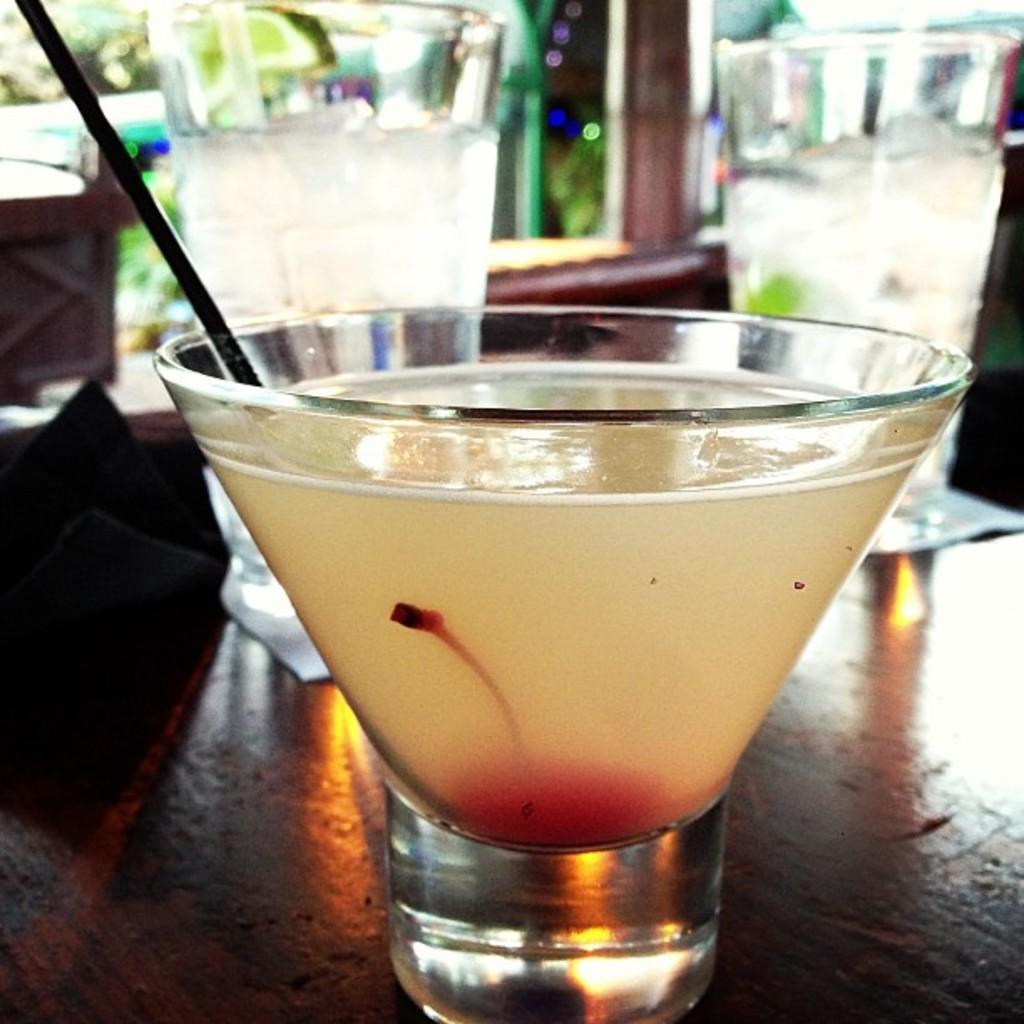How many drink glasses are on the table in the image? There are three drink glasses on the table. Is there anything special about one of the drink glasses? Yes, one of the drink glasses has a straw in it. What type of juice can be seen steaming in the image? There is no juice present in the image, and therefore no steam can be observed. 